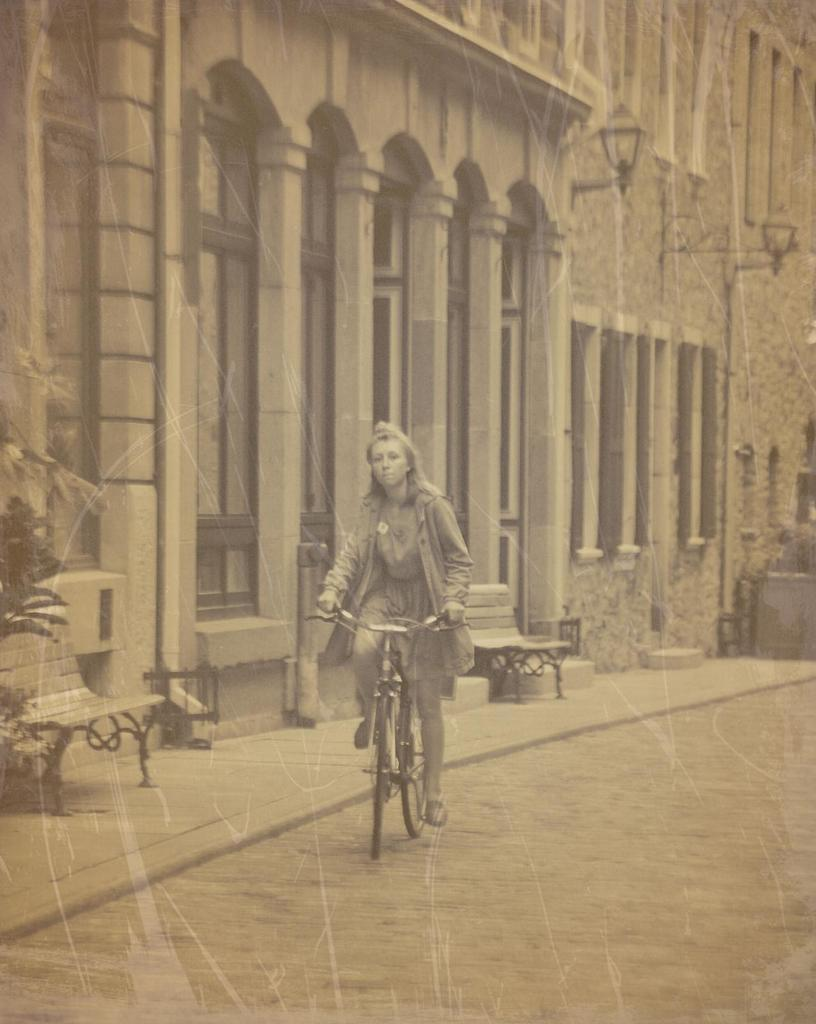What type of structures can be seen in the image? There are buildings in the image. What type of lighting is present in the image? There are street lamps in the image. What type of seating is available in the image? There are benches in the image. What activity is the woman in the image engaged in? A woman is riding a bicycle on the road in the image. Where is the hen located in the image? There is no hen present in the image. Can you describe the material of the skateboard in the image? There is no skateboard present in the image. 